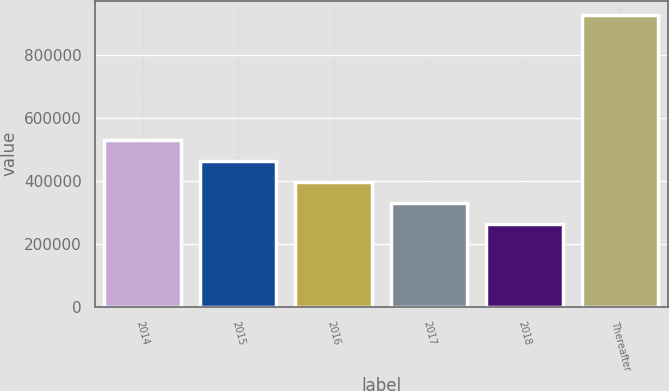Convert chart. <chart><loc_0><loc_0><loc_500><loc_500><bar_chart><fcel>2014<fcel>2015<fcel>2016<fcel>2017<fcel>2018<fcel>Thereafter<nl><fcel>528087<fcel>461856<fcel>395625<fcel>329393<fcel>263162<fcel>925475<nl></chart> 